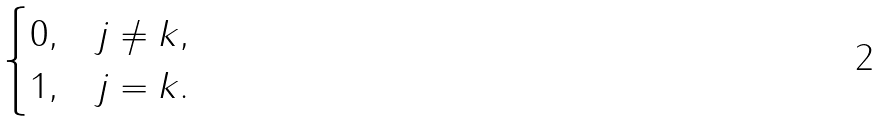Convert formula to latex. <formula><loc_0><loc_0><loc_500><loc_500>\begin{cases} 0 , & j \ne k , \\ 1 , & j = k . \end{cases}</formula> 